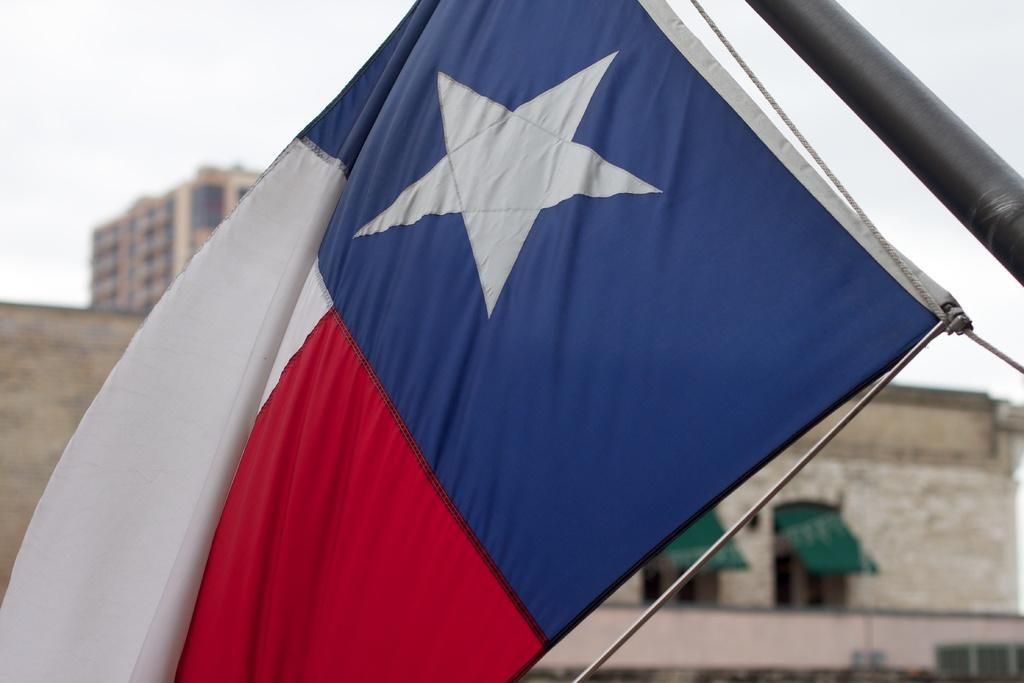What is the main subject in the center of the image? There is a flag in the center of the image. What can be seen in the background of the image? There are buildings, windows, a board, and a rod in the background of the image. What is visible at the top of the image? The sky is visible at the top of the image. Is there anyone driving a vehicle in the image? There is no vehicle or anyone driving in the image; it primarily features a flag and background elements. 